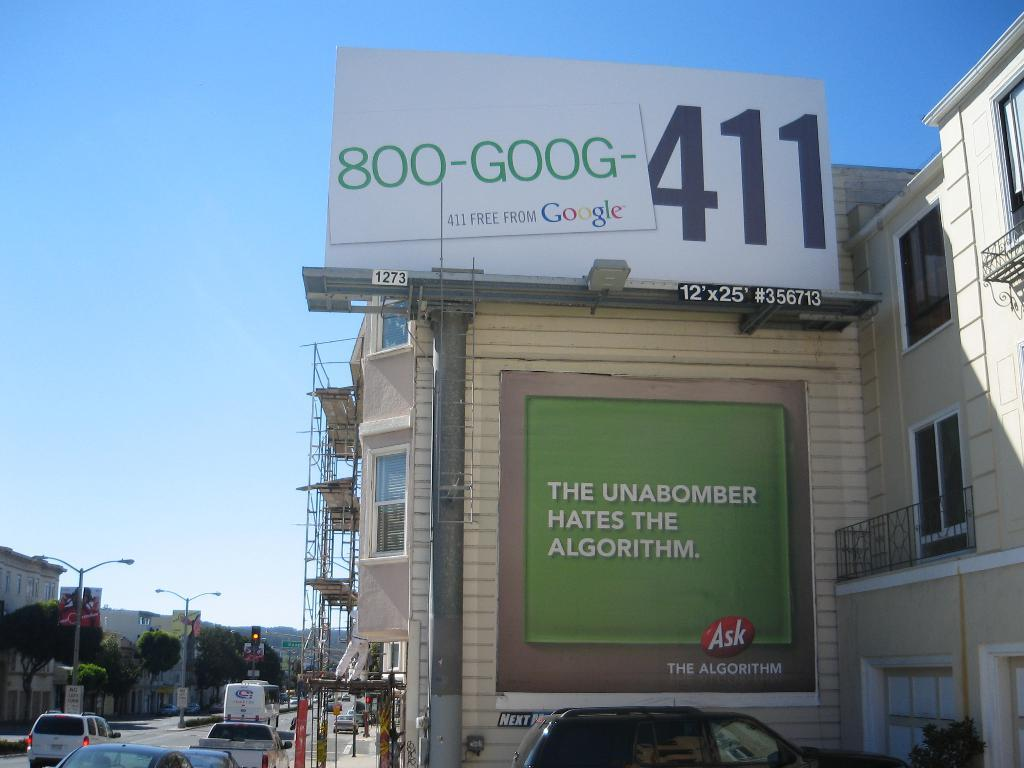<image>
Offer a succinct explanation of the picture presented. A billboard has 800-GOOG in green and 411 in black. 